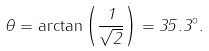Convert formula to latex. <formula><loc_0><loc_0><loc_500><loc_500>\theta = \arctan \left ( \frac { 1 } { \sqrt { 2 } } \right ) = 3 5 . 3 ^ { \circ } .</formula> 